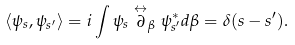Convert formula to latex. <formula><loc_0><loc_0><loc_500><loc_500>\left < \psi _ { s } , \psi _ { s ^ { \prime } } \right > = i \int \psi _ { s } \stackrel { \leftrightarrow } { \partial } _ { \beta } \psi _ { s ^ { \prime } } ^ { * } d \beta = \delta ( s - s ^ { \prime } ) .</formula> 